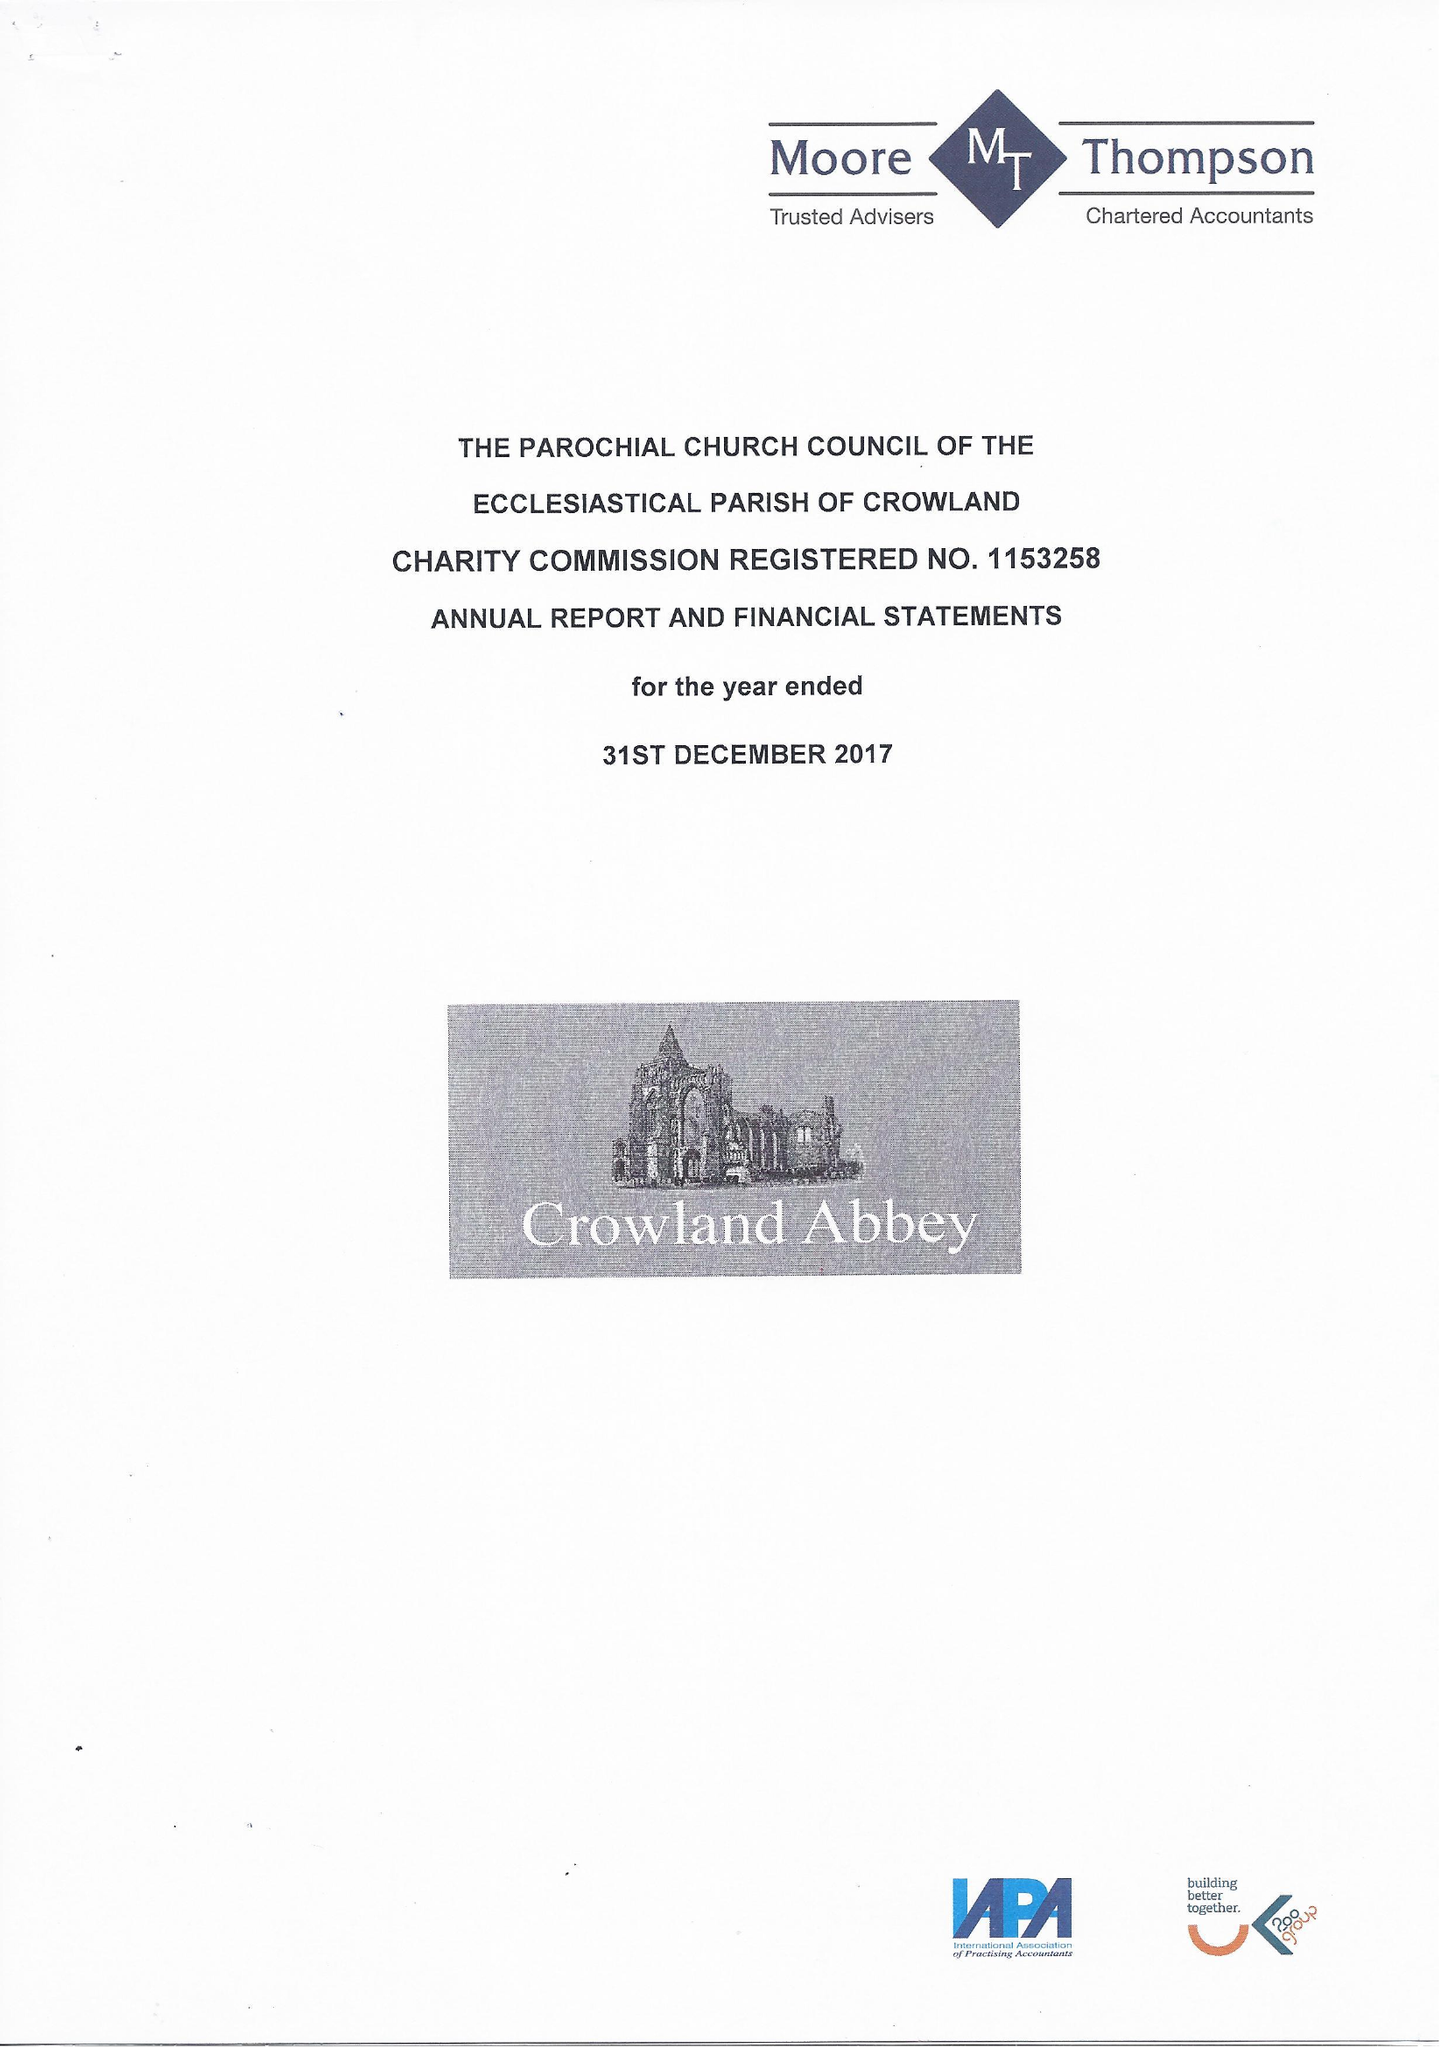What is the value for the spending_annually_in_british_pounds?
Answer the question using a single word or phrase. 96352.00 